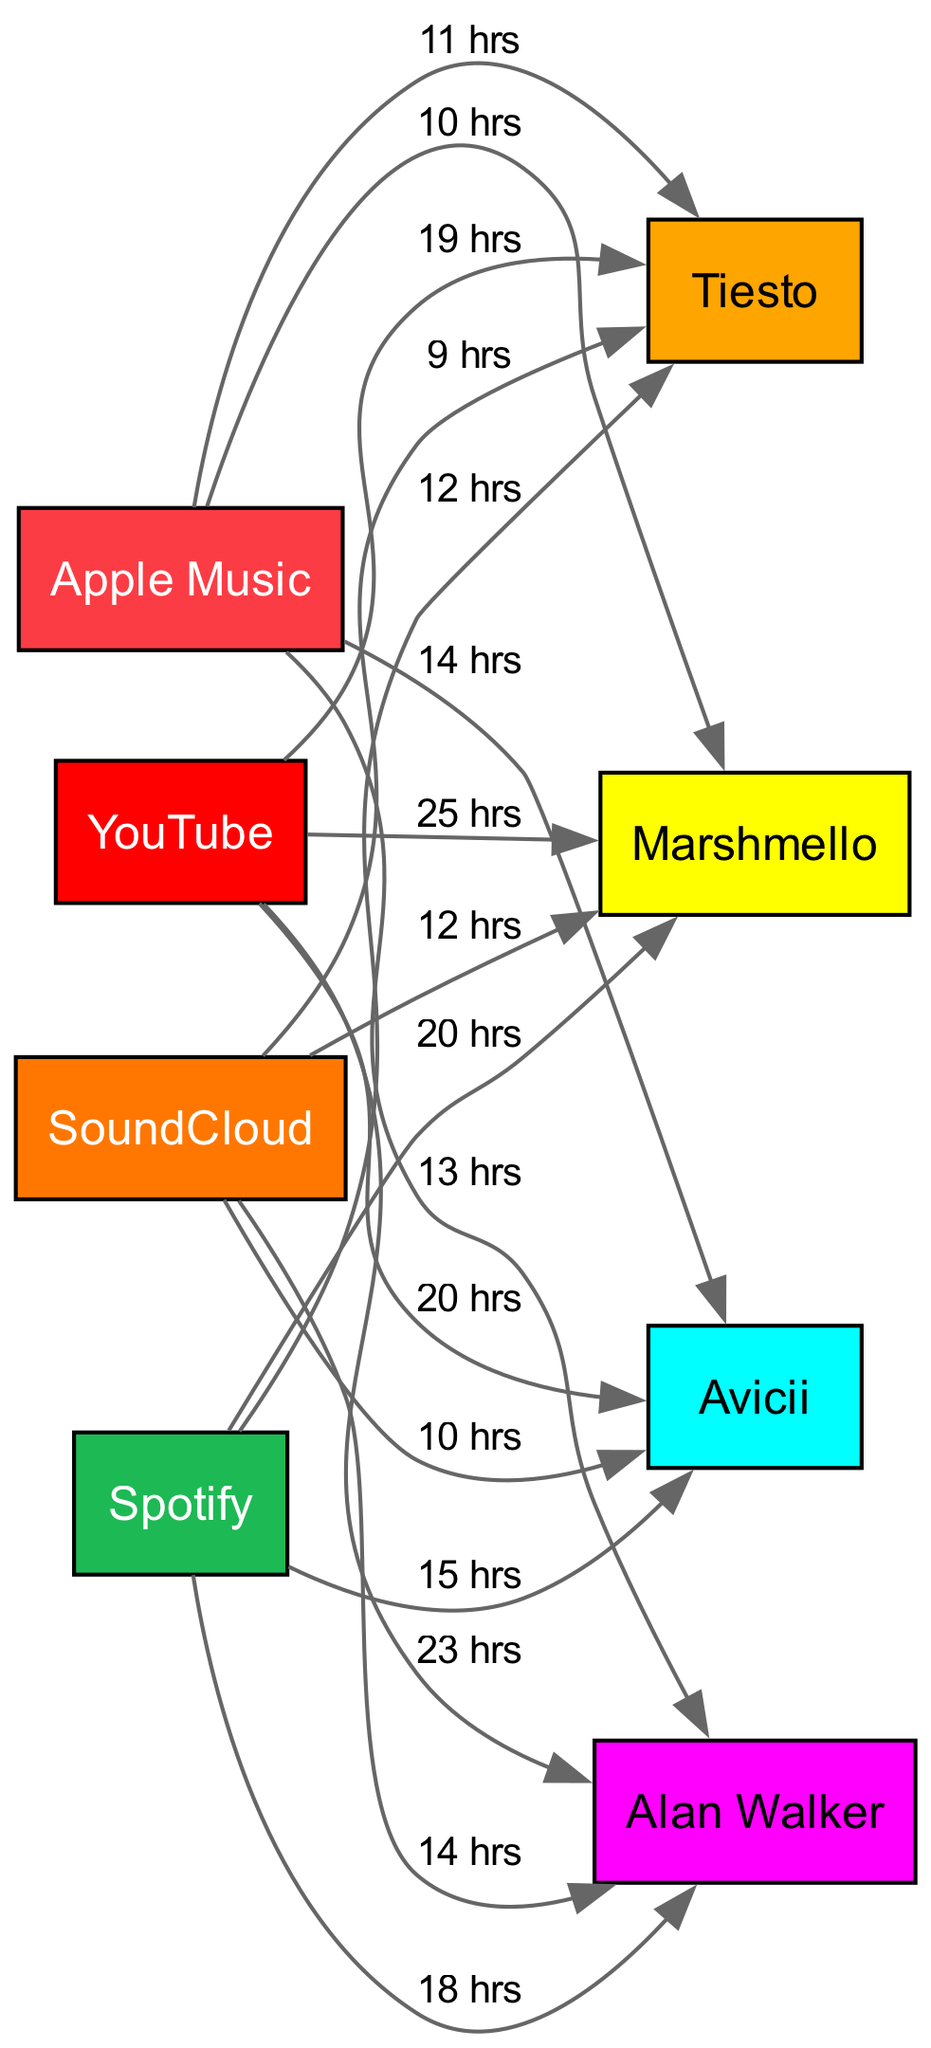What is the total number of platforms in the diagram? The diagram shows nodes for four platforms: Spotify, Apple Music, YouTube, and SoundCloud. By counting these nodes, we find that there are four distinct platforms present.
Answer: 4 Which artist has the highest monthly streaming hours on YouTube? The edge connecting YouTube to Marshmello indicates 25 hours, while the edges for Avicii, Alan Walker, and Tiesto show 20, 23, and 19 hours respectively. Marshmello has the highest value.
Answer: Marshmello How many hours does Tiesto get on Apple Music? By referring to the edge between Apple Music and Tiesto, we see that it shows 11 hours of streaming for Tiesto.
Answer: 11 hrs Which platform has the most total streaming hours for Avicii? The diagram has edges showing 15 hours for Spotify, 14 for Apple Music, 20 for YouTube, and 10 for SoundCloud. Adding these gives 14 + 15 + 20 + 10 = 69 hours, which identifies YouTube as the platform where Avicii is streamed the most.
Answer: YouTube What is the total streaming time for Marshmello across all platforms? Marshmello’s streaming hours are 20 (Spotify) + 10 (Apple Music) + 25 (YouTube) + 12 (SoundCloud), making a total of 20 + 10 + 25 + 12 = 77 hours.
Answer: 77 hrs Which artist has the least streaming hours on SoundCloud? Upon inspecting the edges to SoundCloud, we see that Tiesto has 9 hours, which is lower than the others (Marshmello: 12, Avicii: 10, Alan Walker: 14). Thus, Tiesto has the least streaming hours on SoundCloud.
Answer: Tiesto What color represents SoundCloud in the diagram? The node for SoundCloud may have a distinct color, which can be confirmed in the color scheme provided. SoundCloud is shown with the color #FF7700, representing its unique identity in the diagram.
Answer: Orange How many artists are represented in the diagram? The nodes show four artists: Marshmello, Avicii, Alan Walker, and Tiesto. Counting these nodes, we determine that there are four distinct artists represented in this diagram.
Answer: 4 